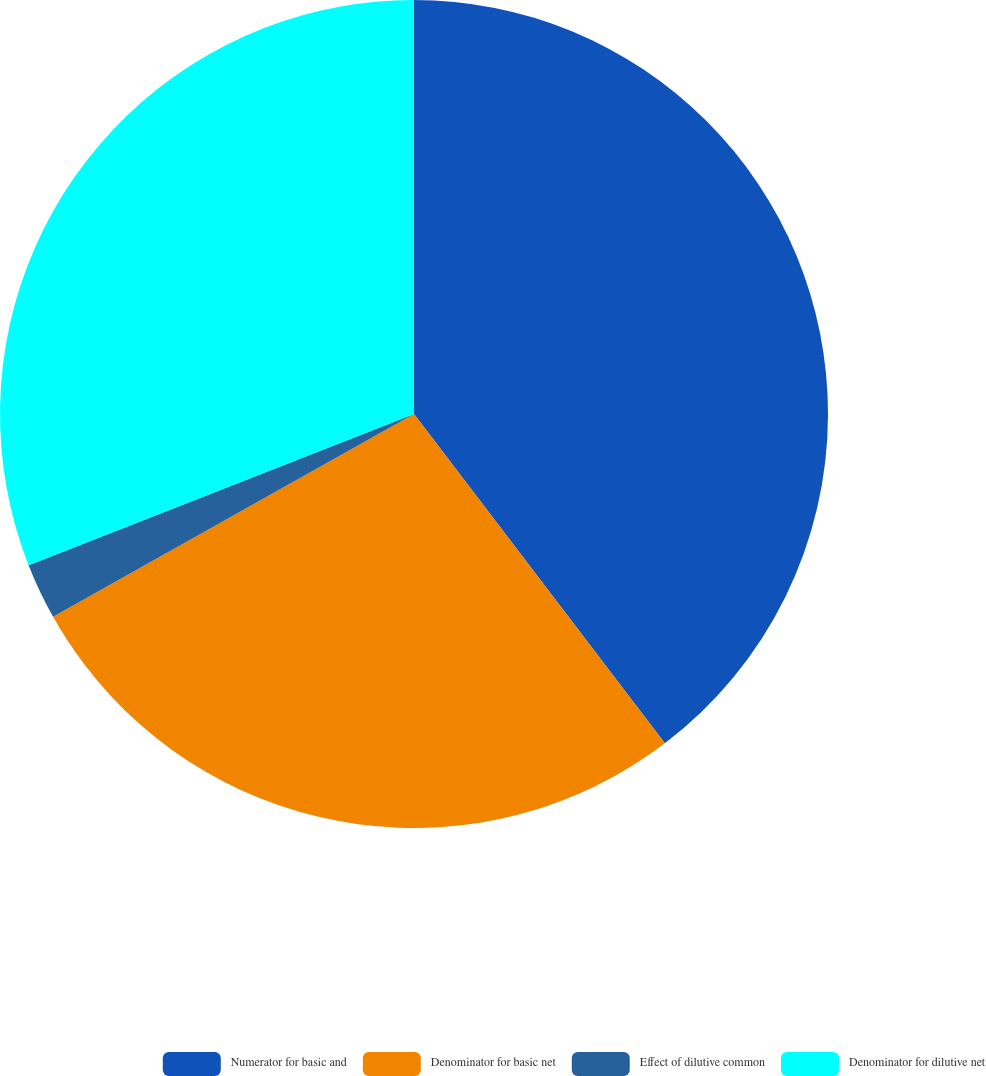Convert chart to OTSL. <chart><loc_0><loc_0><loc_500><loc_500><pie_chart><fcel>Numerator for basic and<fcel>Denominator for basic net<fcel>Effect of dilutive common<fcel>Denominator for dilutive net<nl><fcel>39.64%<fcel>27.21%<fcel>2.2%<fcel>30.95%<nl></chart> 